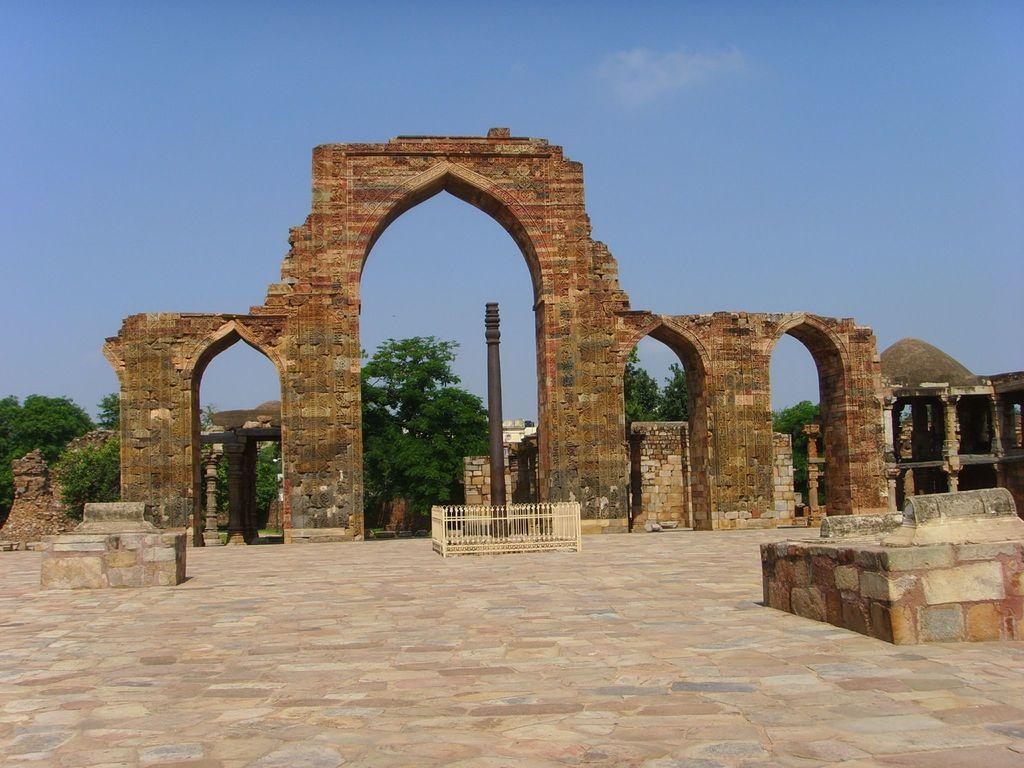What can be seen at the bottom of the image? The floor is visible at the bottom of the image. What is located in the middle of the image? There is a pillar, a fence, walls, a rock, and trees in the middle of the image. What is visible at the top of the image? The sky is visible at the top of the image. What type of cause is being discussed in the image? There is no discussion or mention of a cause in the image; it primarily features a pillar, a fence, walls, a rock, and trees in the middle of the image. Can you describe the garden in the image? There is no garden present in the image; it features a pillar, a fence, walls, a rock, and trees in the middle of the image. 